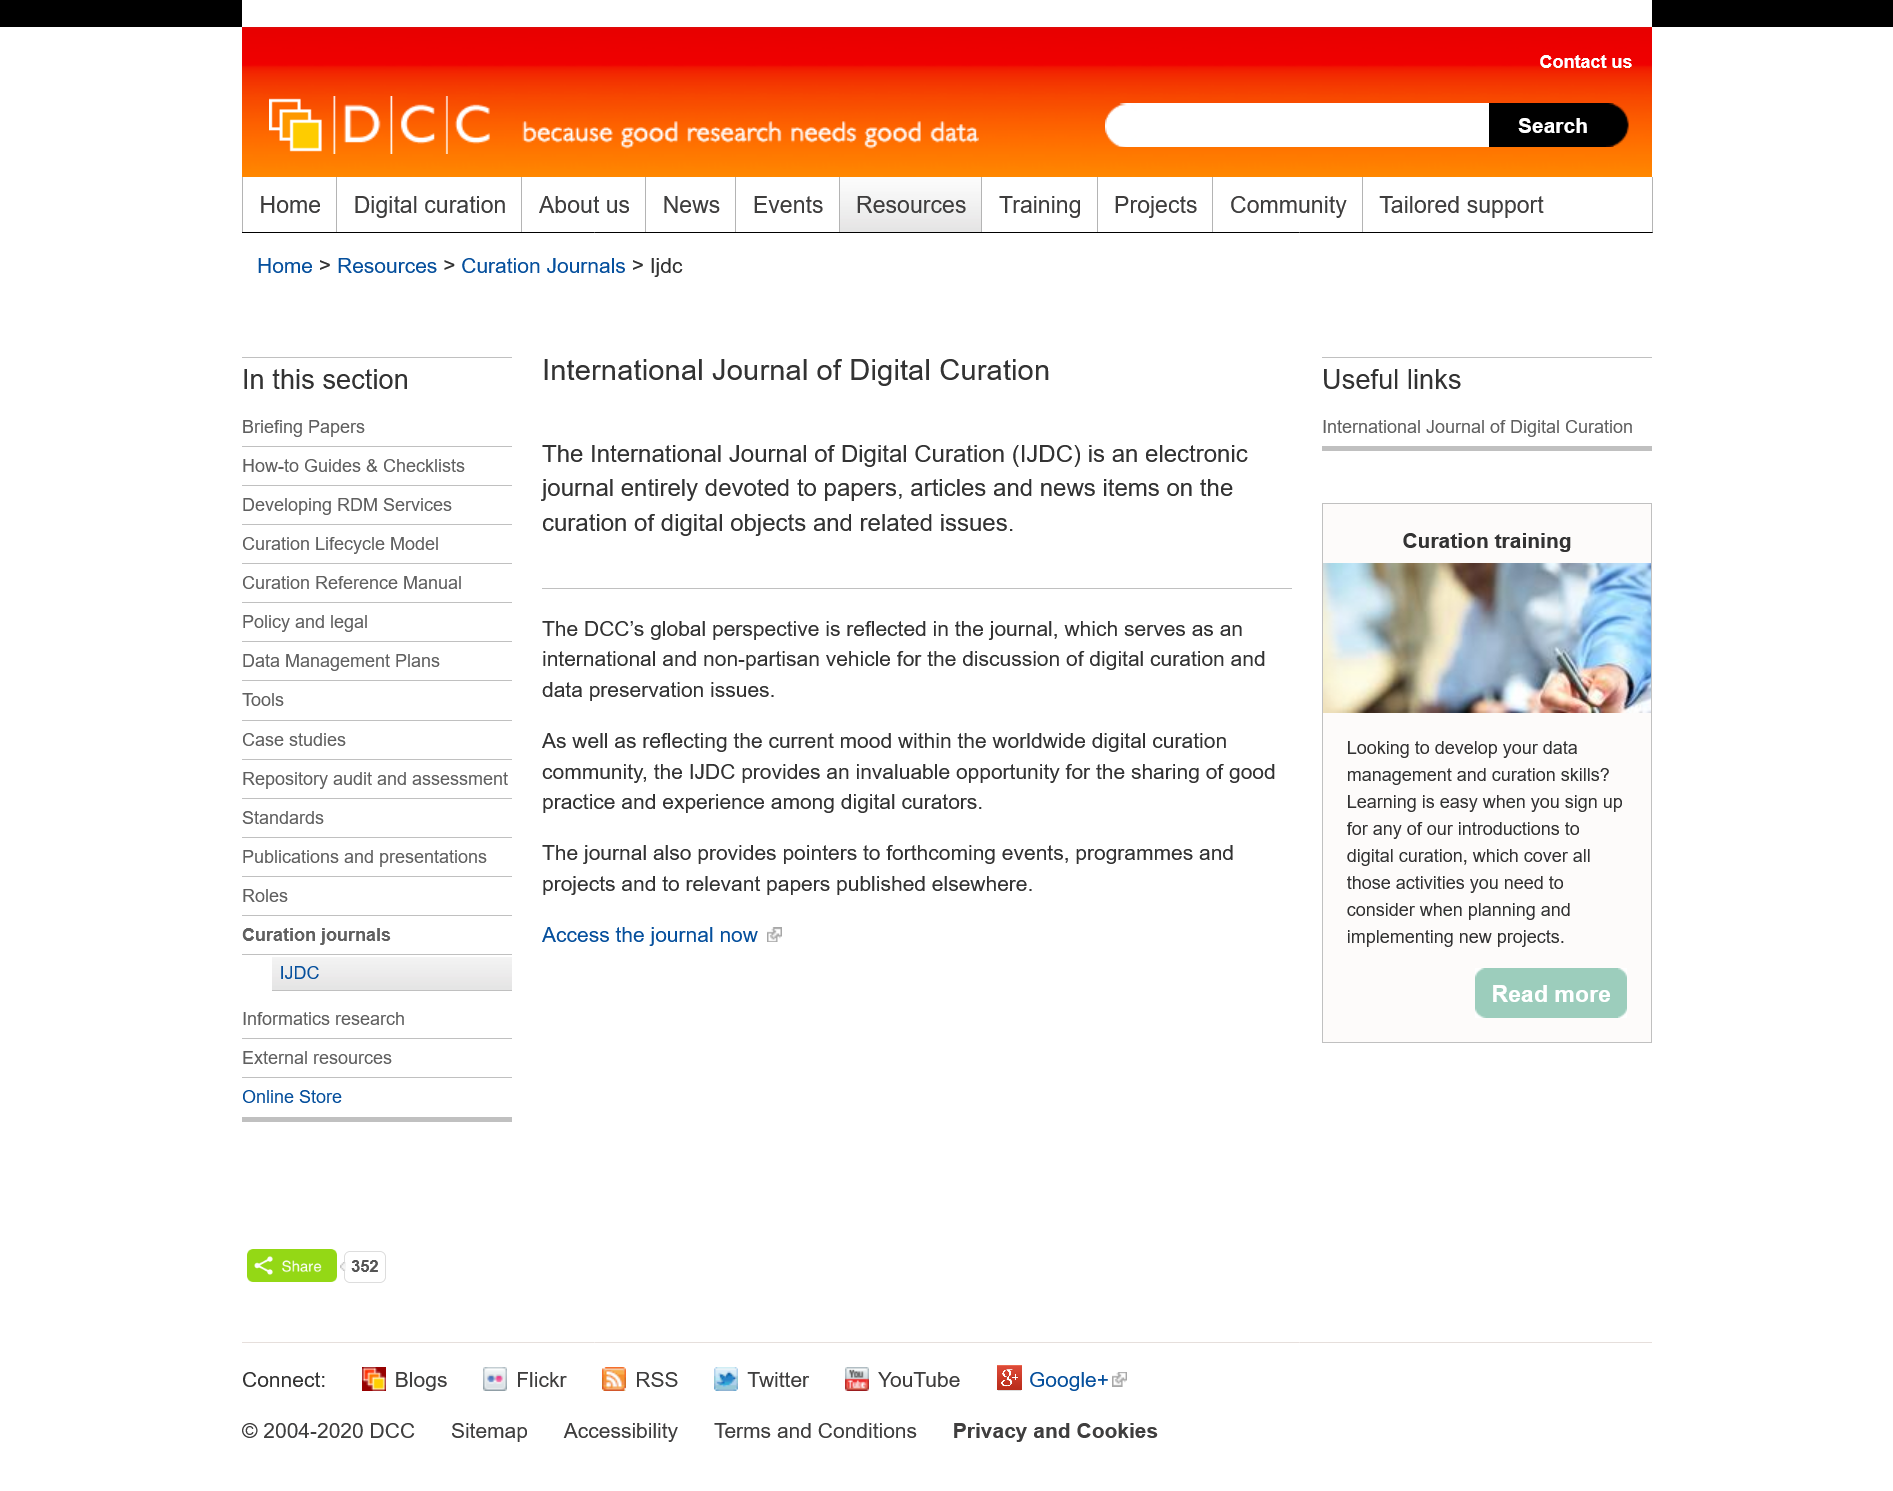Specify some key components in this picture. The International Journal of Digital Curation is an electronic publication that features articles and news items on the preservation and management of digital objects and associated topics. The International Journal of Digital Curation reflects the global perspective of the DCC, which is an organization that has a comprehensive understanding and insight into digital curation practices globally. The International Journal of Digital Curation is also referred to as the IJDC. 